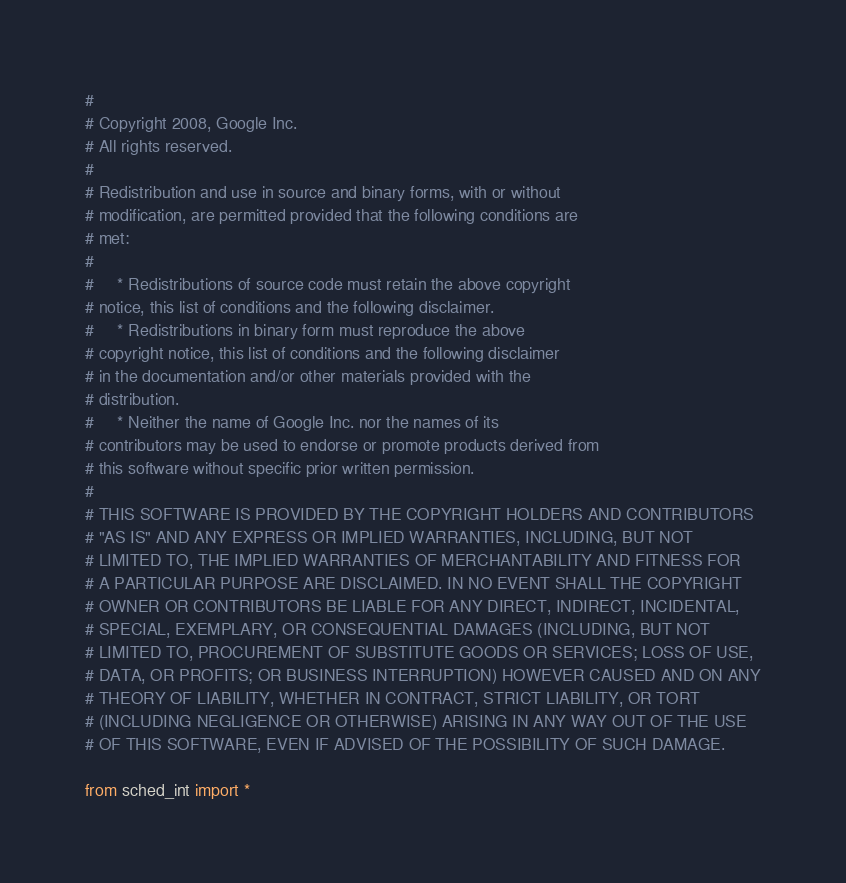<code> <loc_0><loc_0><loc_500><loc_500><_Python_># 
# Copyright 2008, Google Inc.
# All rights reserved.
# 
# Redistribution and use in source and binary forms, with or without
# modification, are permitted provided that the following conditions are
# met:
# 
#     * Redistributions of source code must retain the above copyright
# notice, this list of conditions and the following disclaimer.
#     * Redistributions in binary form must reproduce the above
# copyright notice, this list of conditions and the following disclaimer
# in the documentation and/or other materials provided with the
# distribution.
#     * Neither the name of Google Inc. nor the names of its
# contributors may be used to endorse or promote products derived from
# this software without specific prior written permission.
# 
# THIS SOFTWARE IS PROVIDED BY THE COPYRIGHT HOLDERS AND CONTRIBUTORS
# "AS IS" AND ANY EXPRESS OR IMPLIED WARRANTIES, INCLUDING, BUT NOT
# LIMITED TO, THE IMPLIED WARRANTIES OF MERCHANTABILITY AND FITNESS FOR
# A PARTICULAR PURPOSE ARE DISCLAIMED. IN NO EVENT SHALL THE COPYRIGHT
# OWNER OR CONTRIBUTORS BE LIABLE FOR ANY DIRECT, INDIRECT, INCIDENTAL,
# SPECIAL, EXEMPLARY, OR CONSEQUENTIAL DAMAGES (INCLUDING, BUT NOT
# LIMITED TO, PROCUREMENT OF SUBSTITUTE GOODS OR SERVICES; LOSS OF USE,
# DATA, OR PROFITS; OR BUSINESS INTERRUPTION) HOWEVER CAUSED AND ON ANY
# THEORY OF LIABILITY, WHETHER IN CONTRACT, STRICT LIABILITY, OR TORT
# (INCLUDING NEGLIGENCE OR OTHERWISE) ARISING IN ANY WAY OUT OF THE USE
# OF THIS SOFTWARE, EVEN IF ADVISED OF THE POSSIBILITY OF SUCH DAMAGE.

from sched_int import *
</code> 